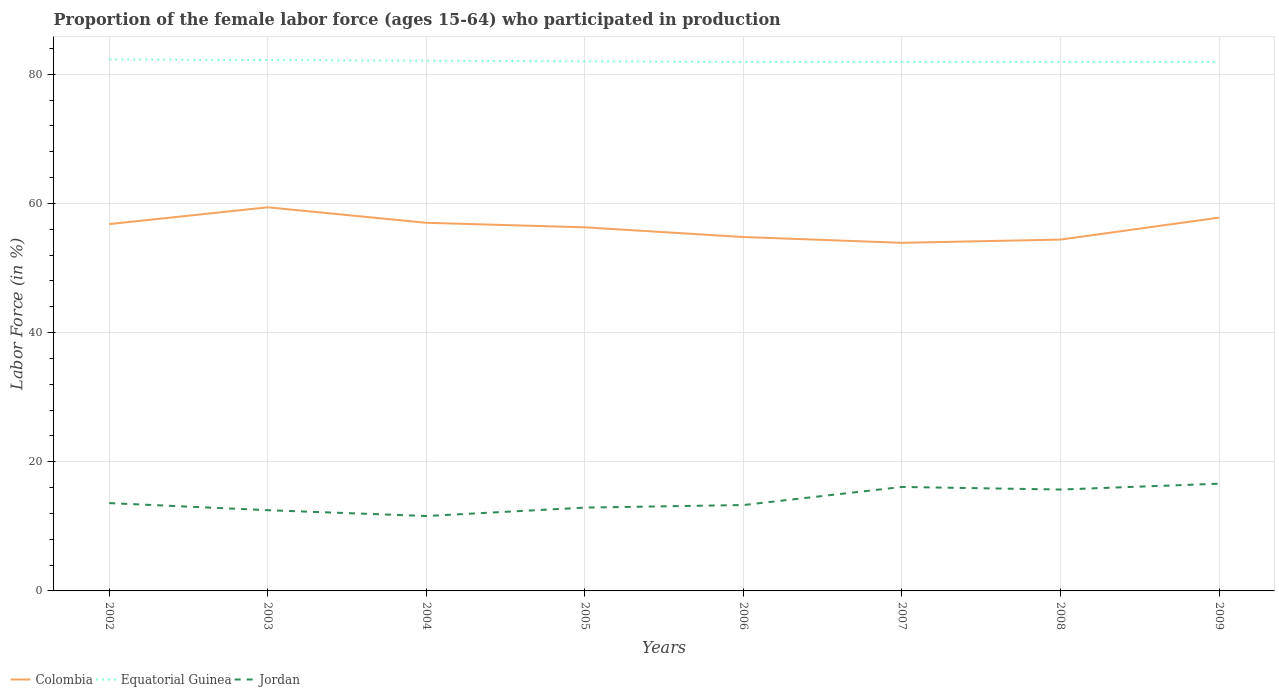Across all years, what is the maximum proportion of the female labor force who participated in production in Jordan?
Give a very brief answer. 11.6. What is the total proportion of the female labor force who participated in production in Equatorial Guinea in the graph?
Provide a short and direct response. 0.1. What is the difference between the highest and the second highest proportion of the female labor force who participated in production in Jordan?
Provide a succinct answer. 5. What is the difference between the highest and the lowest proportion of the female labor force who participated in production in Colombia?
Your response must be concise. 4. Is the proportion of the female labor force who participated in production in Jordan strictly greater than the proportion of the female labor force who participated in production in Colombia over the years?
Offer a terse response. Yes. How many lines are there?
Ensure brevity in your answer.  3. What is the difference between two consecutive major ticks on the Y-axis?
Keep it short and to the point. 20. Are the values on the major ticks of Y-axis written in scientific E-notation?
Keep it short and to the point. No. Where does the legend appear in the graph?
Give a very brief answer. Bottom left. How are the legend labels stacked?
Ensure brevity in your answer.  Horizontal. What is the title of the graph?
Provide a succinct answer. Proportion of the female labor force (ages 15-64) who participated in production. What is the label or title of the X-axis?
Keep it short and to the point. Years. What is the Labor Force (in %) in Colombia in 2002?
Provide a succinct answer. 56.8. What is the Labor Force (in %) in Equatorial Guinea in 2002?
Offer a very short reply. 82.3. What is the Labor Force (in %) of Jordan in 2002?
Ensure brevity in your answer.  13.6. What is the Labor Force (in %) of Colombia in 2003?
Offer a terse response. 59.4. What is the Labor Force (in %) of Equatorial Guinea in 2003?
Provide a succinct answer. 82.2. What is the Labor Force (in %) of Colombia in 2004?
Your response must be concise. 57. What is the Labor Force (in %) of Equatorial Guinea in 2004?
Make the answer very short. 82.1. What is the Labor Force (in %) in Jordan in 2004?
Your answer should be very brief. 11.6. What is the Labor Force (in %) in Colombia in 2005?
Give a very brief answer. 56.3. What is the Labor Force (in %) of Equatorial Guinea in 2005?
Keep it short and to the point. 82. What is the Labor Force (in %) of Jordan in 2005?
Make the answer very short. 12.9. What is the Labor Force (in %) of Colombia in 2006?
Ensure brevity in your answer.  54.8. What is the Labor Force (in %) of Equatorial Guinea in 2006?
Provide a short and direct response. 81.9. What is the Labor Force (in %) in Jordan in 2006?
Make the answer very short. 13.3. What is the Labor Force (in %) of Colombia in 2007?
Ensure brevity in your answer.  53.9. What is the Labor Force (in %) in Equatorial Guinea in 2007?
Provide a succinct answer. 81.9. What is the Labor Force (in %) of Jordan in 2007?
Offer a terse response. 16.1. What is the Labor Force (in %) in Colombia in 2008?
Offer a very short reply. 54.4. What is the Labor Force (in %) in Equatorial Guinea in 2008?
Give a very brief answer. 81.9. What is the Labor Force (in %) in Jordan in 2008?
Make the answer very short. 15.7. What is the Labor Force (in %) in Colombia in 2009?
Provide a short and direct response. 57.8. What is the Labor Force (in %) of Equatorial Guinea in 2009?
Your answer should be compact. 81.9. What is the Labor Force (in %) of Jordan in 2009?
Your answer should be compact. 16.6. Across all years, what is the maximum Labor Force (in %) of Colombia?
Keep it short and to the point. 59.4. Across all years, what is the maximum Labor Force (in %) of Equatorial Guinea?
Your response must be concise. 82.3. Across all years, what is the maximum Labor Force (in %) in Jordan?
Keep it short and to the point. 16.6. Across all years, what is the minimum Labor Force (in %) in Colombia?
Your answer should be very brief. 53.9. Across all years, what is the minimum Labor Force (in %) in Equatorial Guinea?
Your answer should be compact. 81.9. Across all years, what is the minimum Labor Force (in %) of Jordan?
Ensure brevity in your answer.  11.6. What is the total Labor Force (in %) in Colombia in the graph?
Offer a very short reply. 450.4. What is the total Labor Force (in %) of Equatorial Guinea in the graph?
Your answer should be very brief. 656.2. What is the total Labor Force (in %) in Jordan in the graph?
Offer a very short reply. 112.3. What is the difference between the Labor Force (in %) in Equatorial Guinea in 2002 and that in 2003?
Keep it short and to the point. 0.1. What is the difference between the Labor Force (in %) in Jordan in 2002 and that in 2003?
Ensure brevity in your answer.  1.1. What is the difference between the Labor Force (in %) of Equatorial Guinea in 2002 and that in 2004?
Provide a short and direct response. 0.2. What is the difference between the Labor Force (in %) of Colombia in 2002 and that in 2006?
Your response must be concise. 2. What is the difference between the Labor Force (in %) in Equatorial Guinea in 2002 and that in 2006?
Give a very brief answer. 0.4. What is the difference between the Labor Force (in %) of Jordan in 2002 and that in 2007?
Your response must be concise. -2.5. What is the difference between the Labor Force (in %) of Colombia in 2002 and that in 2008?
Your answer should be very brief. 2.4. What is the difference between the Labor Force (in %) in Equatorial Guinea in 2002 and that in 2008?
Make the answer very short. 0.4. What is the difference between the Labor Force (in %) of Jordan in 2002 and that in 2008?
Your response must be concise. -2.1. What is the difference between the Labor Force (in %) of Colombia in 2002 and that in 2009?
Your answer should be very brief. -1. What is the difference between the Labor Force (in %) in Jordan in 2002 and that in 2009?
Your answer should be very brief. -3. What is the difference between the Labor Force (in %) in Colombia in 2003 and that in 2005?
Your answer should be very brief. 3.1. What is the difference between the Labor Force (in %) of Jordan in 2003 and that in 2006?
Give a very brief answer. -0.8. What is the difference between the Labor Force (in %) in Jordan in 2003 and that in 2007?
Offer a very short reply. -3.6. What is the difference between the Labor Force (in %) in Colombia in 2003 and that in 2008?
Keep it short and to the point. 5. What is the difference between the Labor Force (in %) in Equatorial Guinea in 2003 and that in 2008?
Keep it short and to the point. 0.3. What is the difference between the Labor Force (in %) of Colombia in 2003 and that in 2009?
Your answer should be very brief. 1.6. What is the difference between the Labor Force (in %) in Jordan in 2003 and that in 2009?
Ensure brevity in your answer.  -4.1. What is the difference between the Labor Force (in %) in Colombia in 2004 and that in 2005?
Keep it short and to the point. 0.7. What is the difference between the Labor Force (in %) of Jordan in 2004 and that in 2005?
Make the answer very short. -1.3. What is the difference between the Labor Force (in %) of Colombia in 2004 and that in 2006?
Your answer should be very brief. 2.2. What is the difference between the Labor Force (in %) in Jordan in 2004 and that in 2006?
Your answer should be compact. -1.7. What is the difference between the Labor Force (in %) in Colombia in 2004 and that in 2007?
Ensure brevity in your answer.  3.1. What is the difference between the Labor Force (in %) of Jordan in 2004 and that in 2007?
Provide a short and direct response. -4.5. What is the difference between the Labor Force (in %) of Colombia in 2004 and that in 2008?
Give a very brief answer. 2.6. What is the difference between the Labor Force (in %) of Jordan in 2004 and that in 2008?
Provide a short and direct response. -4.1. What is the difference between the Labor Force (in %) of Colombia in 2004 and that in 2009?
Your answer should be compact. -0.8. What is the difference between the Labor Force (in %) of Equatorial Guinea in 2004 and that in 2009?
Your answer should be very brief. 0.2. What is the difference between the Labor Force (in %) of Jordan in 2004 and that in 2009?
Your response must be concise. -5. What is the difference between the Labor Force (in %) of Colombia in 2005 and that in 2007?
Provide a succinct answer. 2.4. What is the difference between the Labor Force (in %) in Equatorial Guinea in 2005 and that in 2007?
Offer a terse response. 0.1. What is the difference between the Labor Force (in %) in Jordan in 2005 and that in 2008?
Ensure brevity in your answer.  -2.8. What is the difference between the Labor Force (in %) in Equatorial Guinea in 2005 and that in 2009?
Make the answer very short. 0.1. What is the difference between the Labor Force (in %) in Equatorial Guinea in 2006 and that in 2008?
Your response must be concise. 0. What is the difference between the Labor Force (in %) of Jordan in 2006 and that in 2008?
Offer a very short reply. -2.4. What is the difference between the Labor Force (in %) of Jordan in 2006 and that in 2009?
Keep it short and to the point. -3.3. What is the difference between the Labor Force (in %) of Equatorial Guinea in 2007 and that in 2008?
Give a very brief answer. 0. What is the difference between the Labor Force (in %) in Jordan in 2007 and that in 2008?
Provide a succinct answer. 0.4. What is the difference between the Labor Force (in %) of Equatorial Guinea in 2007 and that in 2009?
Offer a very short reply. 0. What is the difference between the Labor Force (in %) in Colombia in 2002 and the Labor Force (in %) in Equatorial Guinea in 2003?
Provide a short and direct response. -25.4. What is the difference between the Labor Force (in %) of Colombia in 2002 and the Labor Force (in %) of Jordan in 2003?
Keep it short and to the point. 44.3. What is the difference between the Labor Force (in %) in Equatorial Guinea in 2002 and the Labor Force (in %) in Jordan in 2003?
Give a very brief answer. 69.8. What is the difference between the Labor Force (in %) of Colombia in 2002 and the Labor Force (in %) of Equatorial Guinea in 2004?
Offer a terse response. -25.3. What is the difference between the Labor Force (in %) in Colombia in 2002 and the Labor Force (in %) in Jordan in 2004?
Make the answer very short. 45.2. What is the difference between the Labor Force (in %) of Equatorial Guinea in 2002 and the Labor Force (in %) of Jordan in 2004?
Your answer should be compact. 70.7. What is the difference between the Labor Force (in %) in Colombia in 2002 and the Labor Force (in %) in Equatorial Guinea in 2005?
Keep it short and to the point. -25.2. What is the difference between the Labor Force (in %) in Colombia in 2002 and the Labor Force (in %) in Jordan in 2005?
Make the answer very short. 43.9. What is the difference between the Labor Force (in %) of Equatorial Guinea in 2002 and the Labor Force (in %) of Jordan in 2005?
Offer a very short reply. 69.4. What is the difference between the Labor Force (in %) in Colombia in 2002 and the Labor Force (in %) in Equatorial Guinea in 2006?
Your answer should be very brief. -25.1. What is the difference between the Labor Force (in %) in Colombia in 2002 and the Labor Force (in %) in Jordan in 2006?
Your answer should be very brief. 43.5. What is the difference between the Labor Force (in %) of Equatorial Guinea in 2002 and the Labor Force (in %) of Jordan in 2006?
Your answer should be very brief. 69. What is the difference between the Labor Force (in %) of Colombia in 2002 and the Labor Force (in %) of Equatorial Guinea in 2007?
Keep it short and to the point. -25.1. What is the difference between the Labor Force (in %) in Colombia in 2002 and the Labor Force (in %) in Jordan in 2007?
Keep it short and to the point. 40.7. What is the difference between the Labor Force (in %) of Equatorial Guinea in 2002 and the Labor Force (in %) of Jordan in 2007?
Offer a terse response. 66.2. What is the difference between the Labor Force (in %) in Colombia in 2002 and the Labor Force (in %) in Equatorial Guinea in 2008?
Your response must be concise. -25.1. What is the difference between the Labor Force (in %) of Colombia in 2002 and the Labor Force (in %) of Jordan in 2008?
Your answer should be compact. 41.1. What is the difference between the Labor Force (in %) in Equatorial Guinea in 2002 and the Labor Force (in %) in Jordan in 2008?
Give a very brief answer. 66.6. What is the difference between the Labor Force (in %) of Colombia in 2002 and the Labor Force (in %) of Equatorial Guinea in 2009?
Make the answer very short. -25.1. What is the difference between the Labor Force (in %) of Colombia in 2002 and the Labor Force (in %) of Jordan in 2009?
Offer a terse response. 40.2. What is the difference between the Labor Force (in %) in Equatorial Guinea in 2002 and the Labor Force (in %) in Jordan in 2009?
Your answer should be very brief. 65.7. What is the difference between the Labor Force (in %) of Colombia in 2003 and the Labor Force (in %) of Equatorial Guinea in 2004?
Offer a very short reply. -22.7. What is the difference between the Labor Force (in %) of Colombia in 2003 and the Labor Force (in %) of Jordan in 2004?
Make the answer very short. 47.8. What is the difference between the Labor Force (in %) in Equatorial Guinea in 2003 and the Labor Force (in %) in Jordan in 2004?
Keep it short and to the point. 70.6. What is the difference between the Labor Force (in %) of Colombia in 2003 and the Labor Force (in %) of Equatorial Guinea in 2005?
Your answer should be compact. -22.6. What is the difference between the Labor Force (in %) of Colombia in 2003 and the Labor Force (in %) of Jordan in 2005?
Your response must be concise. 46.5. What is the difference between the Labor Force (in %) in Equatorial Guinea in 2003 and the Labor Force (in %) in Jordan in 2005?
Provide a short and direct response. 69.3. What is the difference between the Labor Force (in %) in Colombia in 2003 and the Labor Force (in %) in Equatorial Guinea in 2006?
Your response must be concise. -22.5. What is the difference between the Labor Force (in %) in Colombia in 2003 and the Labor Force (in %) in Jordan in 2006?
Keep it short and to the point. 46.1. What is the difference between the Labor Force (in %) of Equatorial Guinea in 2003 and the Labor Force (in %) of Jordan in 2006?
Give a very brief answer. 68.9. What is the difference between the Labor Force (in %) in Colombia in 2003 and the Labor Force (in %) in Equatorial Guinea in 2007?
Your answer should be compact. -22.5. What is the difference between the Labor Force (in %) of Colombia in 2003 and the Labor Force (in %) of Jordan in 2007?
Offer a very short reply. 43.3. What is the difference between the Labor Force (in %) in Equatorial Guinea in 2003 and the Labor Force (in %) in Jordan in 2007?
Ensure brevity in your answer.  66.1. What is the difference between the Labor Force (in %) in Colombia in 2003 and the Labor Force (in %) in Equatorial Guinea in 2008?
Your response must be concise. -22.5. What is the difference between the Labor Force (in %) of Colombia in 2003 and the Labor Force (in %) of Jordan in 2008?
Offer a terse response. 43.7. What is the difference between the Labor Force (in %) in Equatorial Guinea in 2003 and the Labor Force (in %) in Jordan in 2008?
Provide a succinct answer. 66.5. What is the difference between the Labor Force (in %) in Colombia in 2003 and the Labor Force (in %) in Equatorial Guinea in 2009?
Ensure brevity in your answer.  -22.5. What is the difference between the Labor Force (in %) in Colombia in 2003 and the Labor Force (in %) in Jordan in 2009?
Your answer should be very brief. 42.8. What is the difference between the Labor Force (in %) in Equatorial Guinea in 2003 and the Labor Force (in %) in Jordan in 2009?
Give a very brief answer. 65.6. What is the difference between the Labor Force (in %) of Colombia in 2004 and the Labor Force (in %) of Jordan in 2005?
Your answer should be compact. 44.1. What is the difference between the Labor Force (in %) in Equatorial Guinea in 2004 and the Labor Force (in %) in Jordan in 2005?
Offer a terse response. 69.2. What is the difference between the Labor Force (in %) in Colombia in 2004 and the Labor Force (in %) in Equatorial Guinea in 2006?
Offer a terse response. -24.9. What is the difference between the Labor Force (in %) of Colombia in 2004 and the Labor Force (in %) of Jordan in 2006?
Ensure brevity in your answer.  43.7. What is the difference between the Labor Force (in %) of Equatorial Guinea in 2004 and the Labor Force (in %) of Jordan in 2006?
Offer a terse response. 68.8. What is the difference between the Labor Force (in %) of Colombia in 2004 and the Labor Force (in %) of Equatorial Guinea in 2007?
Your response must be concise. -24.9. What is the difference between the Labor Force (in %) of Colombia in 2004 and the Labor Force (in %) of Jordan in 2007?
Give a very brief answer. 40.9. What is the difference between the Labor Force (in %) in Colombia in 2004 and the Labor Force (in %) in Equatorial Guinea in 2008?
Provide a short and direct response. -24.9. What is the difference between the Labor Force (in %) in Colombia in 2004 and the Labor Force (in %) in Jordan in 2008?
Provide a short and direct response. 41.3. What is the difference between the Labor Force (in %) of Equatorial Guinea in 2004 and the Labor Force (in %) of Jordan in 2008?
Provide a succinct answer. 66.4. What is the difference between the Labor Force (in %) of Colombia in 2004 and the Labor Force (in %) of Equatorial Guinea in 2009?
Your answer should be compact. -24.9. What is the difference between the Labor Force (in %) in Colombia in 2004 and the Labor Force (in %) in Jordan in 2009?
Your response must be concise. 40.4. What is the difference between the Labor Force (in %) of Equatorial Guinea in 2004 and the Labor Force (in %) of Jordan in 2009?
Offer a very short reply. 65.5. What is the difference between the Labor Force (in %) of Colombia in 2005 and the Labor Force (in %) of Equatorial Guinea in 2006?
Keep it short and to the point. -25.6. What is the difference between the Labor Force (in %) of Colombia in 2005 and the Labor Force (in %) of Jordan in 2006?
Offer a terse response. 43. What is the difference between the Labor Force (in %) in Equatorial Guinea in 2005 and the Labor Force (in %) in Jordan in 2006?
Give a very brief answer. 68.7. What is the difference between the Labor Force (in %) of Colombia in 2005 and the Labor Force (in %) of Equatorial Guinea in 2007?
Offer a very short reply. -25.6. What is the difference between the Labor Force (in %) in Colombia in 2005 and the Labor Force (in %) in Jordan in 2007?
Offer a terse response. 40.2. What is the difference between the Labor Force (in %) of Equatorial Guinea in 2005 and the Labor Force (in %) of Jordan in 2007?
Your response must be concise. 65.9. What is the difference between the Labor Force (in %) of Colombia in 2005 and the Labor Force (in %) of Equatorial Guinea in 2008?
Keep it short and to the point. -25.6. What is the difference between the Labor Force (in %) of Colombia in 2005 and the Labor Force (in %) of Jordan in 2008?
Your answer should be compact. 40.6. What is the difference between the Labor Force (in %) of Equatorial Guinea in 2005 and the Labor Force (in %) of Jordan in 2008?
Your answer should be very brief. 66.3. What is the difference between the Labor Force (in %) in Colombia in 2005 and the Labor Force (in %) in Equatorial Guinea in 2009?
Give a very brief answer. -25.6. What is the difference between the Labor Force (in %) in Colombia in 2005 and the Labor Force (in %) in Jordan in 2009?
Offer a terse response. 39.7. What is the difference between the Labor Force (in %) of Equatorial Guinea in 2005 and the Labor Force (in %) of Jordan in 2009?
Offer a very short reply. 65.4. What is the difference between the Labor Force (in %) of Colombia in 2006 and the Labor Force (in %) of Equatorial Guinea in 2007?
Give a very brief answer. -27.1. What is the difference between the Labor Force (in %) of Colombia in 2006 and the Labor Force (in %) of Jordan in 2007?
Your answer should be very brief. 38.7. What is the difference between the Labor Force (in %) in Equatorial Guinea in 2006 and the Labor Force (in %) in Jordan in 2007?
Give a very brief answer. 65.8. What is the difference between the Labor Force (in %) in Colombia in 2006 and the Labor Force (in %) in Equatorial Guinea in 2008?
Make the answer very short. -27.1. What is the difference between the Labor Force (in %) in Colombia in 2006 and the Labor Force (in %) in Jordan in 2008?
Ensure brevity in your answer.  39.1. What is the difference between the Labor Force (in %) in Equatorial Guinea in 2006 and the Labor Force (in %) in Jordan in 2008?
Make the answer very short. 66.2. What is the difference between the Labor Force (in %) in Colombia in 2006 and the Labor Force (in %) in Equatorial Guinea in 2009?
Offer a very short reply. -27.1. What is the difference between the Labor Force (in %) of Colombia in 2006 and the Labor Force (in %) of Jordan in 2009?
Your answer should be compact. 38.2. What is the difference between the Labor Force (in %) of Equatorial Guinea in 2006 and the Labor Force (in %) of Jordan in 2009?
Offer a very short reply. 65.3. What is the difference between the Labor Force (in %) of Colombia in 2007 and the Labor Force (in %) of Jordan in 2008?
Make the answer very short. 38.2. What is the difference between the Labor Force (in %) in Equatorial Guinea in 2007 and the Labor Force (in %) in Jordan in 2008?
Offer a very short reply. 66.2. What is the difference between the Labor Force (in %) in Colombia in 2007 and the Labor Force (in %) in Equatorial Guinea in 2009?
Ensure brevity in your answer.  -28. What is the difference between the Labor Force (in %) of Colombia in 2007 and the Labor Force (in %) of Jordan in 2009?
Provide a succinct answer. 37.3. What is the difference between the Labor Force (in %) of Equatorial Guinea in 2007 and the Labor Force (in %) of Jordan in 2009?
Your answer should be compact. 65.3. What is the difference between the Labor Force (in %) in Colombia in 2008 and the Labor Force (in %) in Equatorial Guinea in 2009?
Offer a terse response. -27.5. What is the difference between the Labor Force (in %) in Colombia in 2008 and the Labor Force (in %) in Jordan in 2009?
Your response must be concise. 37.8. What is the difference between the Labor Force (in %) of Equatorial Guinea in 2008 and the Labor Force (in %) of Jordan in 2009?
Your answer should be very brief. 65.3. What is the average Labor Force (in %) in Colombia per year?
Your response must be concise. 56.3. What is the average Labor Force (in %) of Equatorial Guinea per year?
Your answer should be very brief. 82.03. What is the average Labor Force (in %) of Jordan per year?
Keep it short and to the point. 14.04. In the year 2002, what is the difference between the Labor Force (in %) in Colombia and Labor Force (in %) in Equatorial Guinea?
Ensure brevity in your answer.  -25.5. In the year 2002, what is the difference between the Labor Force (in %) in Colombia and Labor Force (in %) in Jordan?
Ensure brevity in your answer.  43.2. In the year 2002, what is the difference between the Labor Force (in %) in Equatorial Guinea and Labor Force (in %) in Jordan?
Provide a succinct answer. 68.7. In the year 2003, what is the difference between the Labor Force (in %) in Colombia and Labor Force (in %) in Equatorial Guinea?
Give a very brief answer. -22.8. In the year 2003, what is the difference between the Labor Force (in %) in Colombia and Labor Force (in %) in Jordan?
Make the answer very short. 46.9. In the year 2003, what is the difference between the Labor Force (in %) of Equatorial Guinea and Labor Force (in %) of Jordan?
Offer a very short reply. 69.7. In the year 2004, what is the difference between the Labor Force (in %) of Colombia and Labor Force (in %) of Equatorial Guinea?
Ensure brevity in your answer.  -25.1. In the year 2004, what is the difference between the Labor Force (in %) of Colombia and Labor Force (in %) of Jordan?
Make the answer very short. 45.4. In the year 2004, what is the difference between the Labor Force (in %) of Equatorial Guinea and Labor Force (in %) of Jordan?
Provide a short and direct response. 70.5. In the year 2005, what is the difference between the Labor Force (in %) in Colombia and Labor Force (in %) in Equatorial Guinea?
Provide a short and direct response. -25.7. In the year 2005, what is the difference between the Labor Force (in %) in Colombia and Labor Force (in %) in Jordan?
Provide a succinct answer. 43.4. In the year 2005, what is the difference between the Labor Force (in %) in Equatorial Guinea and Labor Force (in %) in Jordan?
Provide a short and direct response. 69.1. In the year 2006, what is the difference between the Labor Force (in %) in Colombia and Labor Force (in %) in Equatorial Guinea?
Provide a short and direct response. -27.1. In the year 2006, what is the difference between the Labor Force (in %) in Colombia and Labor Force (in %) in Jordan?
Provide a short and direct response. 41.5. In the year 2006, what is the difference between the Labor Force (in %) in Equatorial Guinea and Labor Force (in %) in Jordan?
Give a very brief answer. 68.6. In the year 2007, what is the difference between the Labor Force (in %) in Colombia and Labor Force (in %) in Equatorial Guinea?
Give a very brief answer. -28. In the year 2007, what is the difference between the Labor Force (in %) in Colombia and Labor Force (in %) in Jordan?
Offer a terse response. 37.8. In the year 2007, what is the difference between the Labor Force (in %) of Equatorial Guinea and Labor Force (in %) of Jordan?
Your response must be concise. 65.8. In the year 2008, what is the difference between the Labor Force (in %) of Colombia and Labor Force (in %) of Equatorial Guinea?
Give a very brief answer. -27.5. In the year 2008, what is the difference between the Labor Force (in %) of Colombia and Labor Force (in %) of Jordan?
Your answer should be compact. 38.7. In the year 2008, what is the difference between the Labor Force (in %) of Equatorial Guinea and Labor Force (in %) of Jordan?
Offer a terse response. 66.2. In the year 2009, what is the difference between the Labor Force (in %) of Colombia and Labor Force (in %) of Equatorial Guinea?
Keep it short and to the point. -24.1. In the year 2009, what is the difference between the Labor Force (in %) of Colombia and Labor Force (in %) of Jordan?
Provide a short and direct response. 41.2. In the year 2009, what is the difference between the Labor Force (in %) in Equatorial Guinea and Labor Force (in %) in Jordan?
Provide a short and direct response. 65.3. What is the ratio of the Labor Force (in %) of Colombia in 2002 to that in 2003?
Offer a very short reply. 0.96. What is the ratio of the Labor Force (in %) in Jordan in 2002 to that in 2003?
Offer a very short reply. 1.09. What is the ratio of the Labor Force (in %) of Colombia in 2002 to that in 2004?
Offer a very short reply. 1. What is the ratio of the Labor Force (in %) of Equatorial Guinea in 2002 to that in 2004?
Provide a succinct answer. 1. What is the ratio of the Labor Force (in %) in Jordan in 2002 to that in 2004?
Your answer should be compact. 1.17. What is the ratio of the Labor Force (in %) in Colombia in 2002 to that in 2005?
Provide a short and direct response. 1.01. What is the ratio of the Labor Force (in %) of Equatorial Guinea in 2002 to that in 2005?
Provide a short and direct response. 1. What is the ratio of the Labor Force (in %) in Jordan in 2002 to that in 2005?
Your response must be concise. 1.05. What is the ratio of the Labor Force (in %) of Colombia in 2002 to that in 2006?
Your answer should be compact. 1.04. What is the ratio of the Labor Force (in %) of Jordan in 2002 to that in 2006?
Provide a succinct answer. 1.02. What is the ratio of the Labor Force (in %) of Colombia in 2002 to that in 2007?
Keep it short and to the point. 1.05. What is the ratio of the Labor Force (in %) of Equatorial Guinea in 2002 to that in 2007?
Keep it short and to the point. 1. What is the ratio of the Labor Force (in %) of Jordan in 2002 to that in 2007?
Keep it short and to the point. 0.84. What is the ratio of the Labor Force (in %) of Colombia in 2002 to that in 2008?
Make the answer very short. 1.04. What is the ratio of the Labor Force (in %) of Jordan in 2002 to that in 2008?
Keep it short and to the point. 0.87. What is the ratio of the Labor Force (in %) in Colombia in 2002 to that in 2009?
Offer a very short reply. 0.98. What is the ratio of the Labor Force (in %) of Equatorial Guinea in 2002 to that in 2009?
Offer a terse response. 1. What is the ratio of the Labor Force (in %) of Jordan in 2002 to that in 2009?
Your response must be concise. 0.82. What is the ratio of the Labor Force (in %) of Colombia in 2003 to that in 2004?
Make the answer very short. 1.04. What is the ratio of the Labor Force (in %) of Jordan in 2003 to that in 2004?
Ensure brevity in your answer.  1.08. What is the ratio of the Labor Force (in %) in Colombia in 2003 to that in 2005?
Your answer should be very brief. 1.06. What is the ratio of the Labor Force (in %) in Equatorial Guinea in 2003 to that in 2005?
Offer a terse response. 1. What is the ratio of the Labor Force (in %) in Colombia in 2003 to that in 2006?
Offer a very short reply. 1.08. What is the ratio of the Labor Force (in %) of Jordan in 2003 to that in 2006?
Provide a short and direct response. 0.94. What is the ratio of the Labor Force (in %) of Colombia in 2003 to that in 2007?
Make the answer very short. 1.1. What is the ratio of the Labor Force (in %) of Jordan in 2003 to that in 2007?
Provide a succinct answer. 0.78. What is the ratio of the Labor Force (in %) in Colombia in 2003 to that in 2008?
Ensure brevity in your answer.  1.09. What is the ratio of the Labor Force (in %) of Equatorial Guinea in 2003 to that in 2008?
Give a very brief answer. 1. What is the ratio of the Labor Force (in %) in Jordan in 2003 to that in 2008?
Offer a terse response. 0.8. What is the ratio of the Labor Force (in %) in Colombia in 2003 to that in 2009?
Keep it short and to the point. 1.03. What is the ratio of the Labor Force (in %) of Equatorial Guinea in 2003 to that in 2009?
Keep it short and to the point. 1. What is the ratio of the Labor Force (in %) of Jordan in 2003 to that in 2009?
Your response must be concise. 0.75. What is the ratio of the Labor Force (in %) in Colombia in 2004 to that in 2005?
Your answer should be compact. 1.01. What is the ratio of the Labor Force (in %) of Equatorial Guinea in 2004 to that in 2005?
Provide a succinct answer. 1. What is the ratio of the Labor Force (in %) of Jordan in 2004 to that in 2005?
Offer a terse response. 0.9. What is the ratio of the Labor Force (in %) of Colombia in 2004 to that in 2006?
Make the answer very short. 1.04. What is the ratio of the Labor Force (in %) of Jordan in 2004 to that in 2006?
Offer a terse response. 0.87. What is the ratio of the Labor Force (in %) of Colombia in 2004 to that in 2007?
Ensure brevity in your answer.  1.06. What is the ratio of the Labor Force (in %) of Equatorial Guinea in 2004 to that in 2007?
Give a very brief answer. 1. What is the ratio of the Labor Force (in %) of Jordan in 2004 to that in 2007?
Provide a succinct answer. 0.72. What is the ratio of the Labor Force (in %) of Colombia in 2004 to that in 2008?
Provide a succinct answer. 1.05. What is the ratio of the Labor Force (in %) in Jordan in 2004 to that in 2008?
Provide a short and direct response. 0.74. What is the ratio of the Labor Force (in %) of Colombia in 2004 to that in 2009?
Keep it short and to the point. 0.99. What is the ratio of the Labor Force (in %) in Jordan in 2004 to that in 2009?
Keep it short and to the point. 0.7. What is the ratio of the Labor Force (in %) of Colombia in 2005 to that in 2006?
Provide a short and direct response. 1.03. What is the ratio of the Labor Force (in %) of Jordan in 2005 to that in 2006?
Your answer should be compact. 0.97. What is the ratio of the Labor Force (in %) of Colombia in 2005 to that in 2007?
Provide a succinct answer. 1.04. What is the ratio of the Labor Force (in %) in Equatorial Guinea in 2005 to that in 2007?
Provide a succinct answer. 1. What is the ratio of the Labor Force (in %) of Jordan in 2005 to that in 2007?
Offer a very short reply. 0.8. What is the ratio of the Labor Force (in %) of Colombia in 2005 to that in 2008?
Your answer should be very brief. 1.03. What is the ratio of the Labor Force (in %) in Equatorial Guinea in 2005 to that in 2008?
Make the answer very short. 1. What is the ratio of the Labor Force (in %) of Jordan in 2005 to that in 2008?
Offer a terse response. 0.82. What is the ratio of the Labor Force (in %) of Jordan in 2005 to that in 2009?
Ensure brevity in your answer.  0.78. What is the ratio of the Labor Force (in %) of Colombia in 2006 to that in 2007?
Your answer should be compact. 1.02. What is the ratio of the Labor Force (in %) in Jordan in 2006 to that in 2007?
Your response must be concise. 0.83. What is the ratio of the Labor Force (in %) of Colombia in 2006 to that in 2008?
Offer a terse response. 1.01. What is the ratio of the Labor Force (in %) in Equatorial Guinea in 2006 to that in 2008?
Provide a short and direct response. 1. What is the ratio of the Labor Force (in %) of Jordan in 2006 to that in 2008?
Ensure brevity in your answer.  0.85. What is the ratio of the Labor Force (in %) in Colombia in 2006 to that in 2009?
Offer a terse response. 0.95. What is the ratio of the Labor Force (in %) in Equatorial Guinea in 2006 to that in 2009?
Your answer should be compact. 1. What is the ratio of the Labor Force (in %) in Jordan in 2006 to that in 2009?
Provide a succinct answer. 0.8. What is the ratio of the Labor Force (in %) of Jordan in 2007 to that in 2008?
Make the answer very short. 1.03. What is the ratio of the Labor Force (in %) of Colombia in 2007 to that in 2009?
Provide a short and direct response. 0.93. What is the ratio of the Labor Force (in %) of Jordan in 2007 to that in 2009?
Make the answer very short. 0.97. What is the ratio of the Labor Force (in %) of Colombia in 2008 to that in 2009?
Your response must be concise. 0.94. What is the ratio of the Labor Force (in %) in Jordan in 2008 to that in 2009?
Your answer should be compact. 0.95. What is the difference between the highest and the second highest Labor Force (in %) in Colombia?
Keep it short and to the point. 1.6. What is the difference between the highest and the second highest Labor Force (in %) of Equatorial Guinea?
Provide a succinct answer. 0.1. What is the difference between the highest and the second highest Labor Force (in %) in Jordan?
Offer a very short reply. 0.5. 